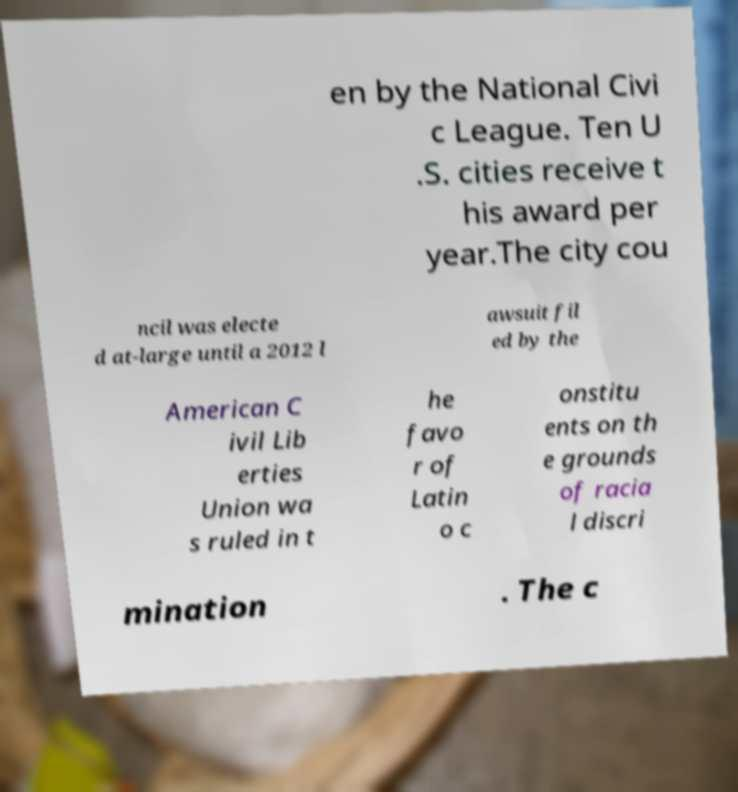Please read and relay the text visible in this image. What does it say? en by the National Civi c League. Ten U .S. cities receive t his award per year.The city cou ncil was electe d at-large until a 2012 l awsuit fil ed by the American C ivil Lib erties Union wa s ruled in t he favo r of Latin o c onstitu ents on th e grounds of racia l discri mination . The c 